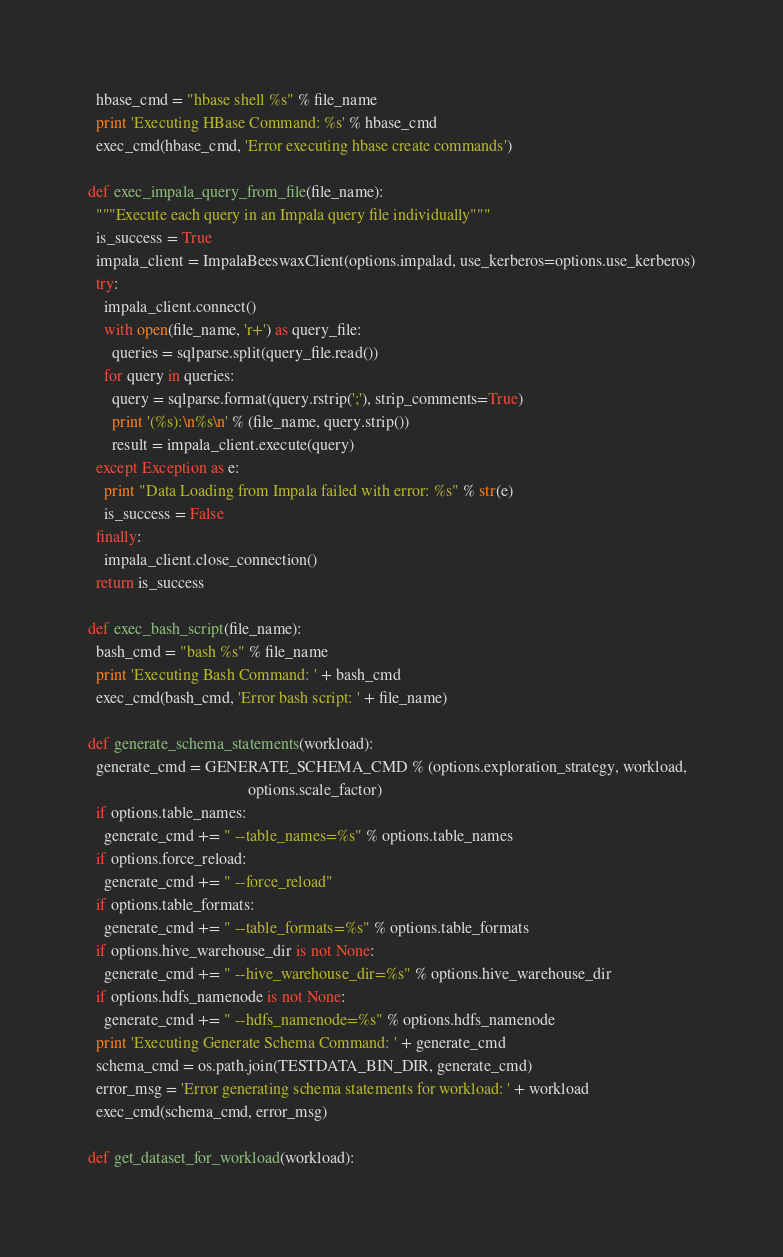<code> <loc_0><loc_0><loc_500><loc_500><_Python_>  hbase_cmd = "hbase shell %s" % file_name
  print 'Executing HBase Command: %s' % hbase_cmd
  exec_cmd(hbase_cmd, 'Error executing hbase create commands')

def exec_impala_query_from_file(file_name):
  """Execute each query in an Impala query file individually"""
  is_success = True
  impala_client = ImpalaBeeswaxClient(options.impalad, use_kerberos=options.use_kerberos)
  try:
    impala_client.connect()
    with open(file_name, 'r+') as query_file:
      queries = sqlparse.split(query_file.read())
    for query in queries:
      query = sqlparse.format(query.rstrip(';'), strip_comments=True)
      print '(%s):\n%s\n' % (file_name, query.strip())
      result = impala_client.execute(query)
  except Exception as e:
    print "Data Loading from Impala failed with error: %s" % str(e)
    is_success = False
  finally:
    impala_client.close_connection()
  return is_success

def exec_bash_script(file_name):
  bash_cmd = "bash %s" % file_name
  print 'Executing Bash Command: ' + bash_cmd
  exec_cmd(bash_cmd, 'Error bash script: ' + file_name)

def generate_schema_statements(workload):
  generate_cmd = GENERATE_SCHEMA_CMD % (options.exploration_strategy, workload,
                                        options.scale_factor)
  if options.table_names:
    generate_cmd += " --table_names=%s" % options.table_names
  if options.force_reload:
    generate_cmd += " --force_reload"
  if options.table_formats:
    generate_cmd += " --table_formats=%s" % options.table_formats
  if options.hive_warehouse_dir is not None:
    generate_cmd += " --hive_warehouse_dir=%s" % options.hive_warehouse_dir
  if options.hdfs_namenode is not None:
    generate_cmd += " --hdfs_namenode=%s" % options.hdfs_namenode
  print 'Executing Generate Schema Command: ' + generate_cmd
  schema_cmd = os.path.join(TESTDATA_BIN_DIR, generate_cmd)
  error_msg = 'Error generating schema statements for workload: ' + workload
  exec_cmd(schema_cmd, error_msg)

def get_dataset_for_workload(workload):</code> 